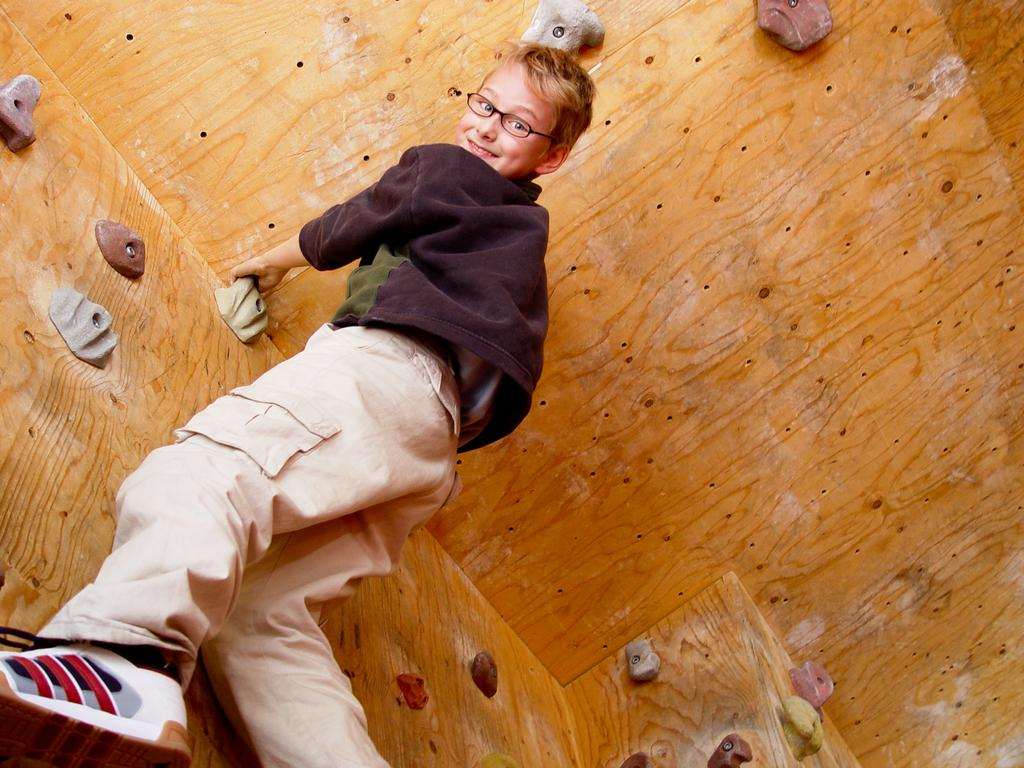What is the main subject of the picture? The main subject of the picture is a kid. What can be observed about the kid's appearance? The kid is wearing spectacles. What is the kid's facial expression in the picture? The kid is smiling. What activity is the kid engaged in? The kid is performing indoor rock climbing. What type of pin is holding the kid's shirt together in the image? There is no pin visible in the image; the kid is wearing spectacles, not a shirt. 